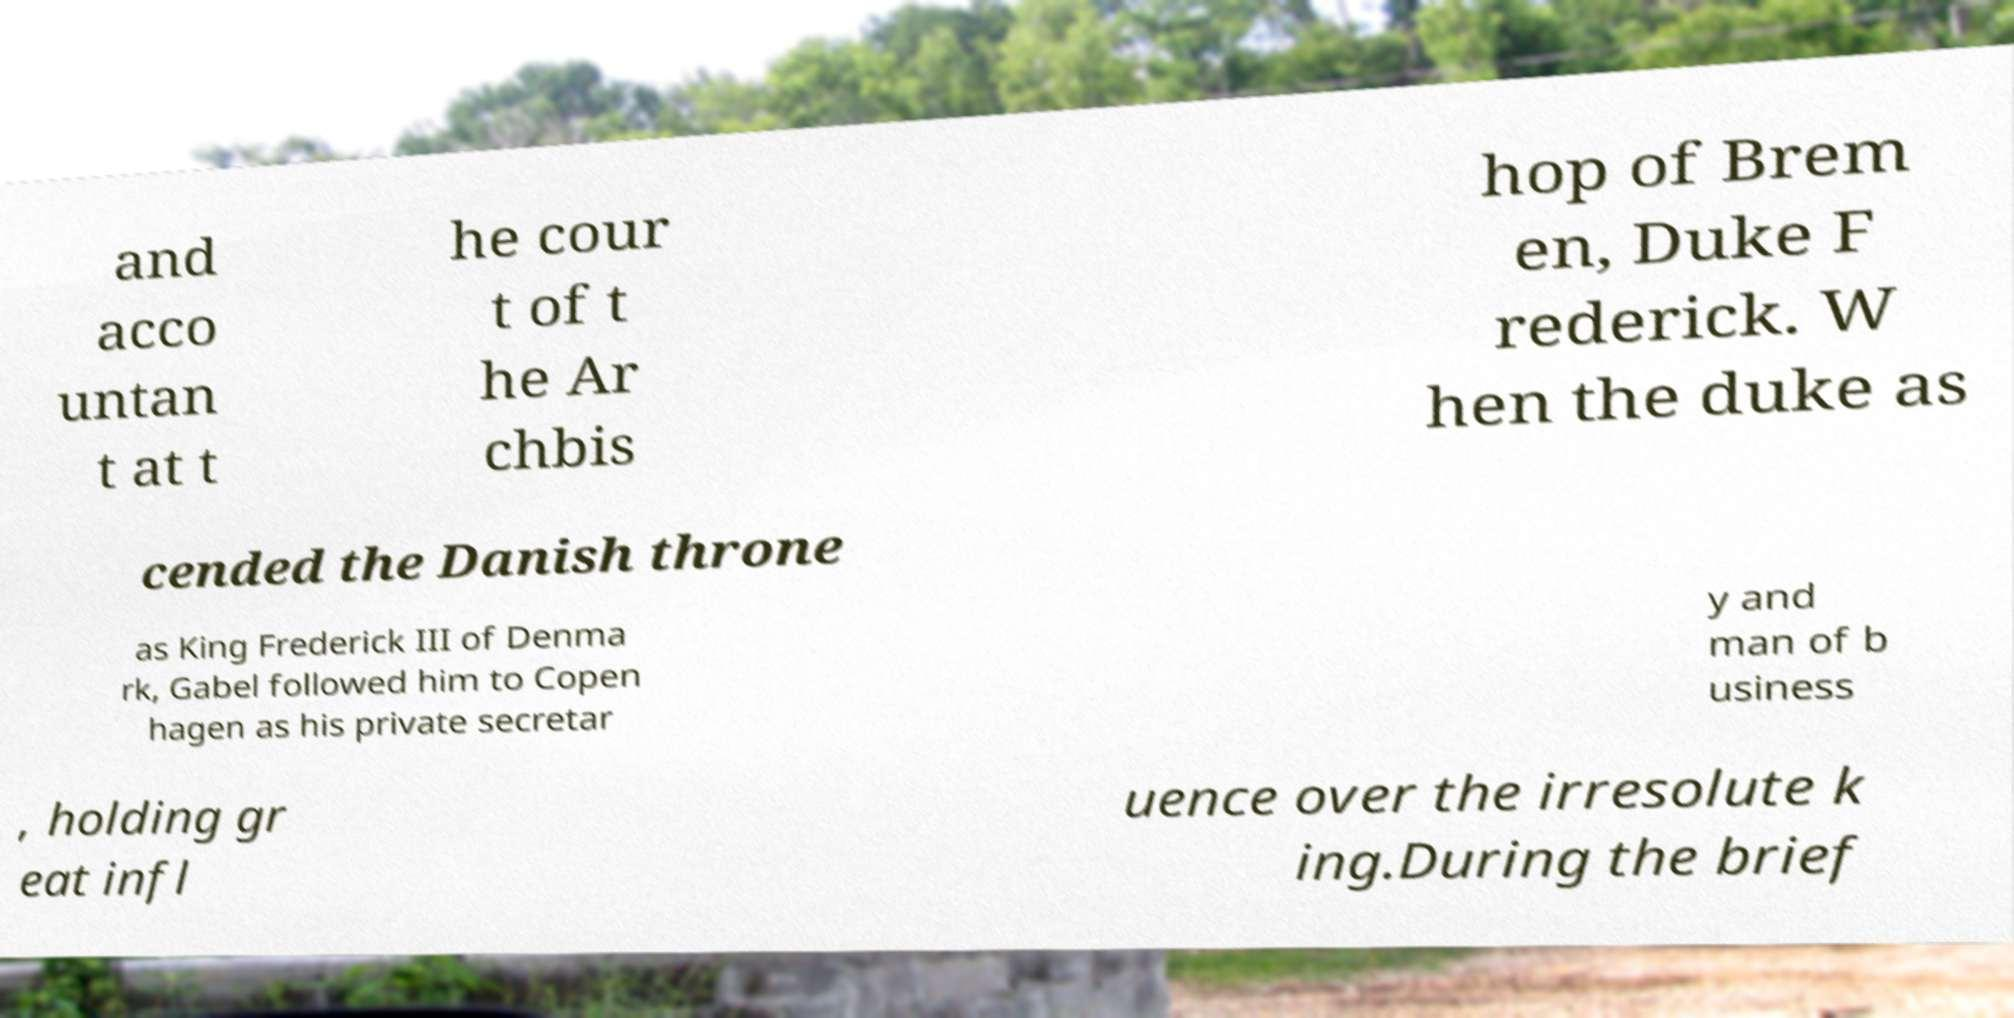Could you assist in decoding the text presented in this image and type it out clearly? and acco untan t at t he cour t of t he Ar chbis hop of Brem en, Duke F rederick. W hen the duke as cended the Danish throne as King Frederick III of Denma rk, Gabel followed him to Copen hagen as his private secretar y and man of b usiness , holding gr eat infl uence over the irresolute k ing.During the brief 